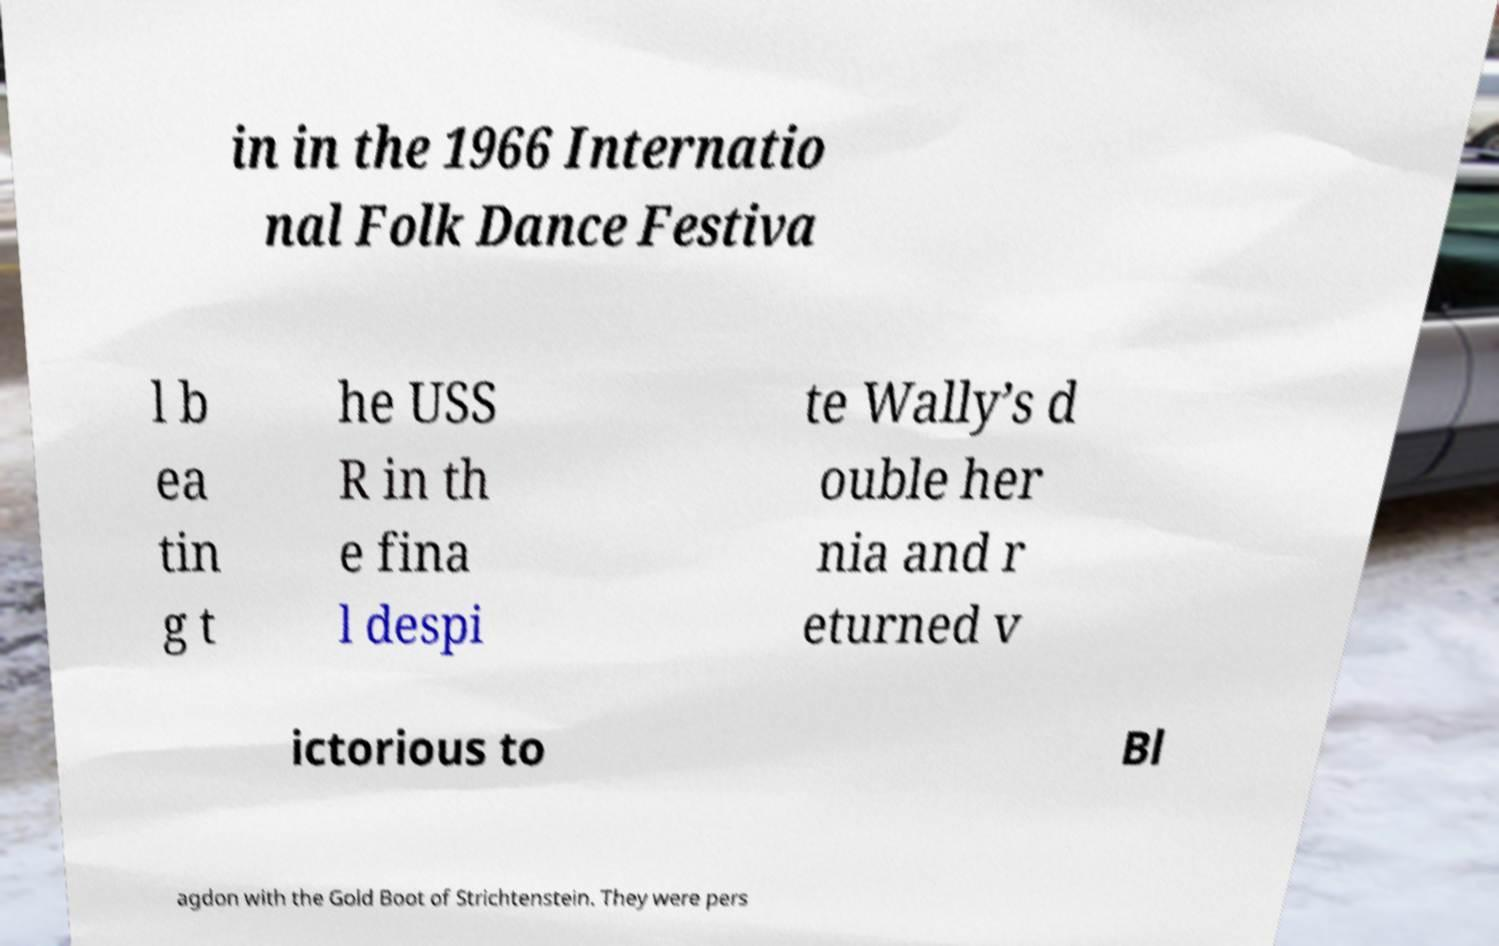Could you extract and type out the text from this image? in in the 1966 Internatio nal Folk Dance Festiva l b ea tin g t he USS R in th e fina l despi te Wally’s d ouble her nia and r eturned v ictorious to Bl agdon with the Gold Boot of Strichtenstein. They were pers 